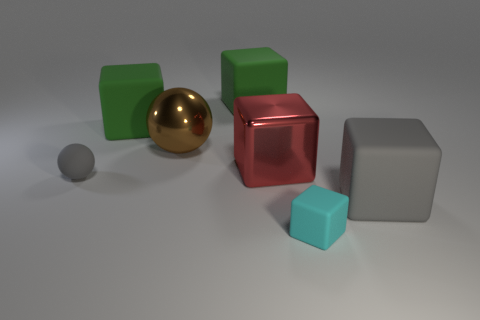Are there any metallic cubes that have the same size as the metal sphere?
Ensure brevity in your answer.  Yes. There is another small object that is the same shape as the red thing; what is it made of?
Your answer should be compact. Rubber. There is a shiny object that is the same size as the metallic cube; what is its shape?
Offer a terse response. Sphere. Is there another matte thing that has the same shape as the small cyan matte object?
Provide a short and direct response. Yes. There is a big matte thing in front of the large green matte block that is left of the large brown shiny sphere; what is its shape?
Your response must be concise. Cube. What is the shape of the brown metallic thing?
Your response must be concise. Sphere. What is the large brown ball that is to the left of the gray matte object that is to the right of the small object that is on the left side of the red shiny cube made of?
Provide a succinct answer. Metal. How many other objects are the same material as the cyan cube?
Your answer should be compact. 4. There is a green object to the left of the brown ball; what number of green objects are to the right of it?
Give a very brief answer. 1. What number of cubes are big green objects or large red objects?
Offer a very short reply. 3. 